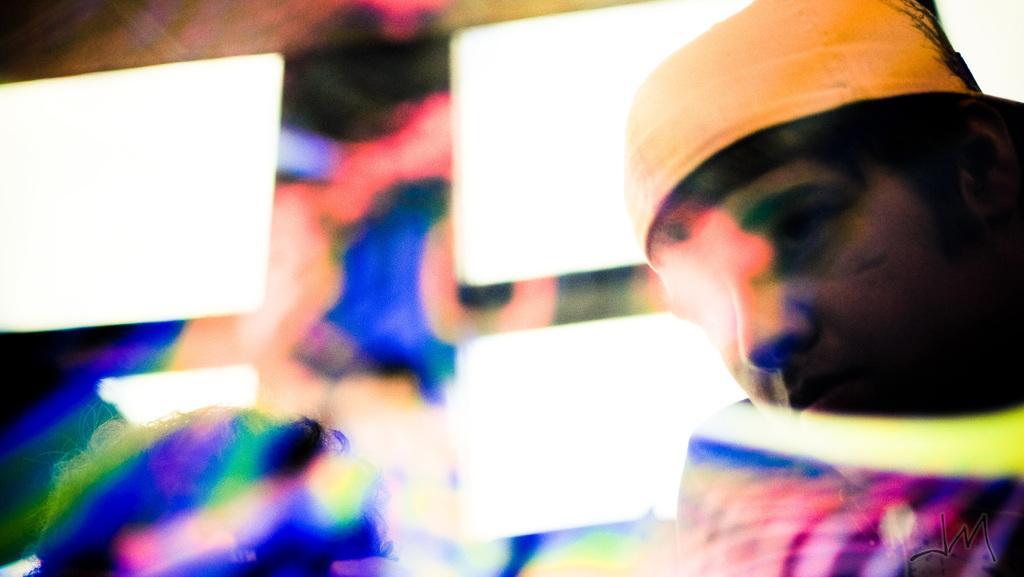Could you give a brief overview of what you see in this image? On the right side of the picture we can see a person's face. Remaining portion of the picture is colorful. 